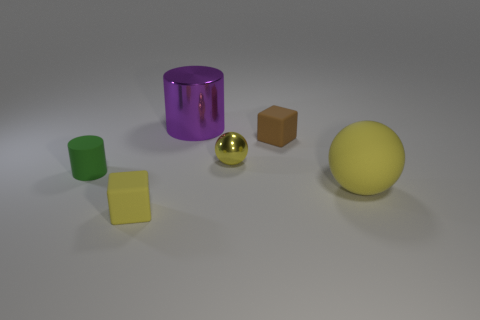There is another small object that is the same shape as the brown rubber object; what material is it?
Offer a terse response. Rubber. Is the number of cyan metallic spheres greater than the number of large rubber objects?
Make the answer very short. No. Is the color of the tiny rubber cylinder the same as the sphere right of the yellow shiny sphere?
Offer a very short reply. No. What color is the small rubber object that is behind the big rubber sphere and on the right side of the green rubber thing?
Make the answer very short. Brown. What number of other things are the same material as the small yellow ball?
Offer a terse response. 1. Are there fewer big shiny things than blue shiny blocks?
Your response must be concise. No. Is the big purple cylinder made of the same material as the small yellow thing right of the large purple cylinder?
Offer a very short reply. Yes. What shape is the rubber thing behind the green object?
Give a very brief answer. Cube. Is there any other thing that is the same color as the tiny metallic object?
Keep it short and to the point. Yes. Are there fewer yellow rubber spheres left of the tiny brown rubber object than yellow shiny things?
Provide a short and direct response. Yes. 